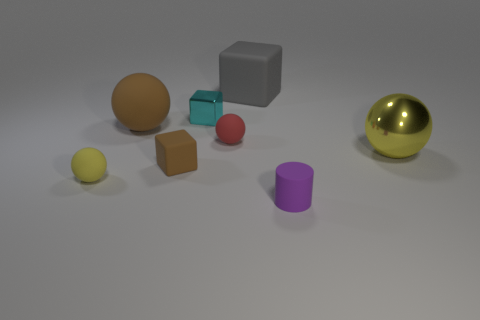Subtract all cyan cubes. Subtract all brown spheres. How many cubes are left? 2 Add 1 tiny cyan metallic spheres. How many objects exist? 9 Subtract all cylinders. How many objects are left? 7 Add 6 large yellow metallic spheres. How many large yellow metallic spheres exist? 7 Subtract 1 brown blocks. How many objects are left? 7 Subtract all large gray blocks. Subtract all red matte objects. How many objects are left? 6 Add 4 shiny objects. How many shiny objects are left? 6 